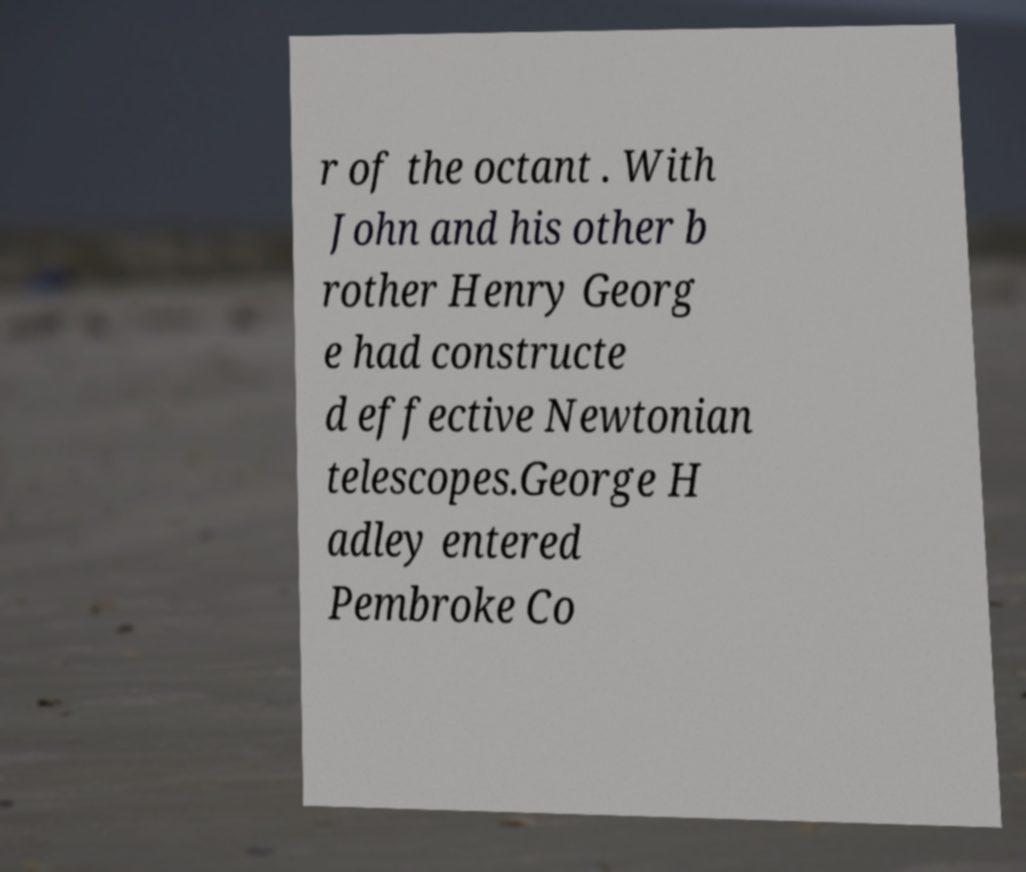Can you read and provide the text displayed in the image?This photo seems to have some interesting text. Can you extract and type it out for me? r of the octant . With John and his other b rother Henry Georg e had constructe d effective Newtonian telescopes.George H adley entered Pembroke Co 